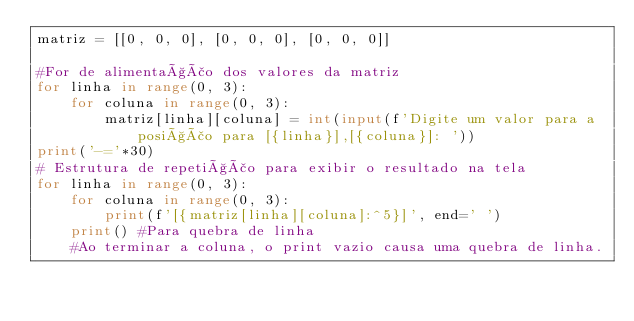<code> <loc_0><loc_0><loc_500><loc_500><_Python_>matriz = [[0, 0, 0], [0, 0, 0], [0, 0, 0]]

#For de alimentação dos valores da matriz
for linha in range(0, 3):
    for coluna in range(0, 3):
        matriz[linha][coluna] = int(input(f'Digite um valor para a posição para [{linha}],[{coluna}]: '))
print('-='*30)
# Estrutura de repetição para exibir o resultado na tela
for linha in range(0, 3):
    for coluna in range(0, 3):
        print(f'[{matriz[linha][coluna]:^5}]', end=' ')
    print() #Para quebra de linha
    #Ao terminar a coluna, o print vazio causa uma quebra de linha.</code> 